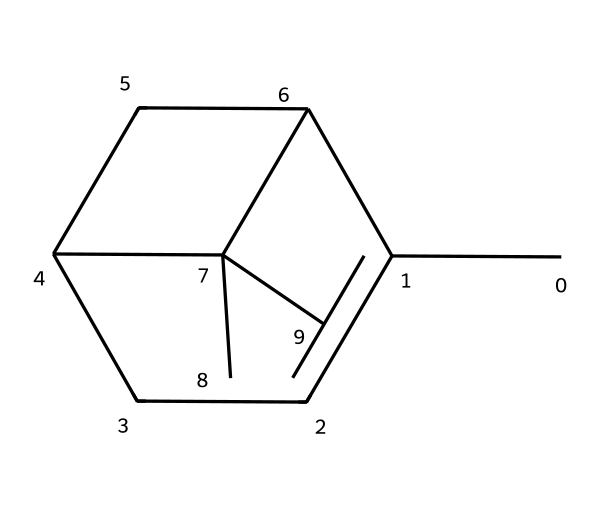What is the molecular formula of alpha-pinene? The chemical structure provided can be analyzed by counting the number of carbon atoms (C) and hydrogen atoms (H) visible in the SMILES notation. In this case, the structure's count reveals 10 carbon atoms and 16 hydrogen atoms, leading to the molecular formula C10H16.
Answer: C10H16 How many rings are present in alpha-pinene's structure? Analyzing the cyclic portions of the structure in the SMILES notation, we can identify the cycles indicated by the numbers. In the case of alpha-pinene, there are two distinct cyclic structures present, forming one of the key characteristics of terpenes.
Answer: 2 Is alpha-pinene a bicyclic compound? Understanding the structure, we see that alpha-pinene is made up of two interconnected rings, which is synonymous with the definition of a bicyclic compound. The presence of the two rings sharing common atoms confirms this classification.
Answer: Yes What type of hydrocarbon does alpha-pinene represent? As we examine the structure, it contains only carbon and hydrogen atoms without any functional groups, categorizing it specifically as a terpene. Terpenes are a specific class of hydrocarbons primarily derived from plants.
Answer: Terpene What is the main functional characteristic of terpenes like alpha-pinene? In addition to their respective structures, terpenes like alpha-pinene are known for their aromatic properties, contributing to scents and flavors. Their structure, specifically the arrangement and types of bonds present, adds to their distinctive aromatic characteristics.
Answer: Aromatic What aldehydes might be produced upon oxidizing alpha-pinene? Considering the molecular structure and the possible sites for oxidation, alpha-pinene can undergo oxidation at the double bond, leading to the formation of products such as aldehydes—specifically, it could yield compounds like pinanal. This oxidation reaction is a common transformation for terpenes.
Answer: Pinanal 